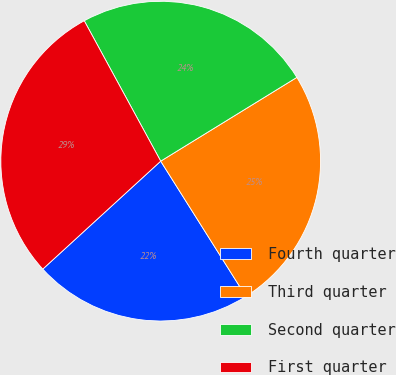<chart> <loc_0><loc_0><loc_500><loc_500><pie_chart><fcel>Fourth quarter<fcel>Third quarter<fcel>Second quarter<fcel>First quarter<nl><fcel>22.15%<fcel>24.83%<fcel>24.16%<fcel>28.86%<nl></chart> 